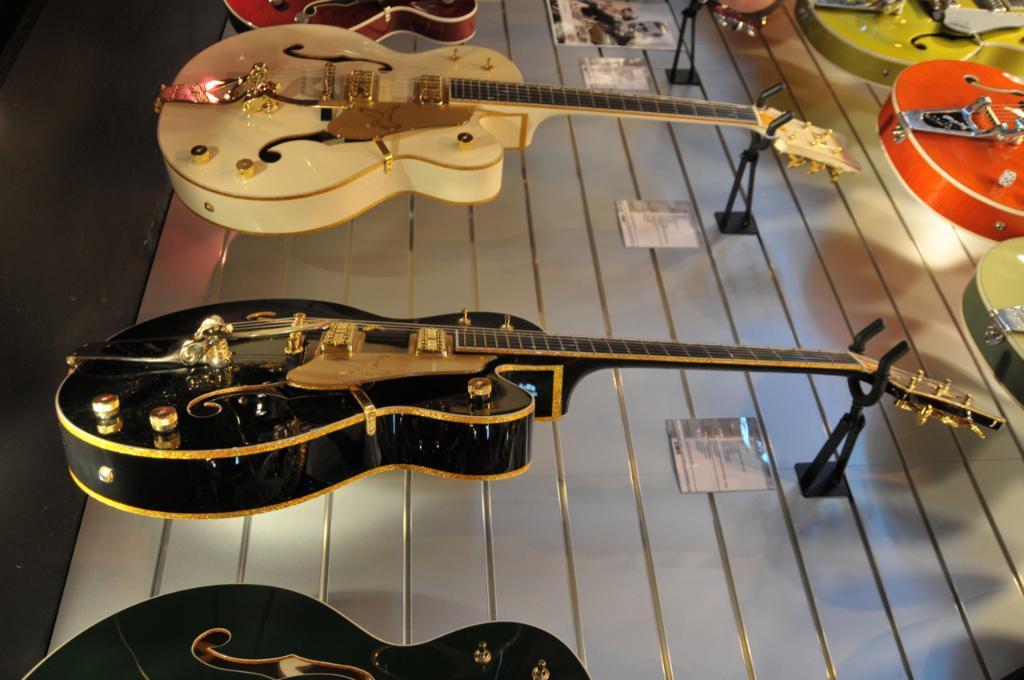Can you describe this image briefly? In this image there are guitars with different colors like green, orange, black, red and white. 